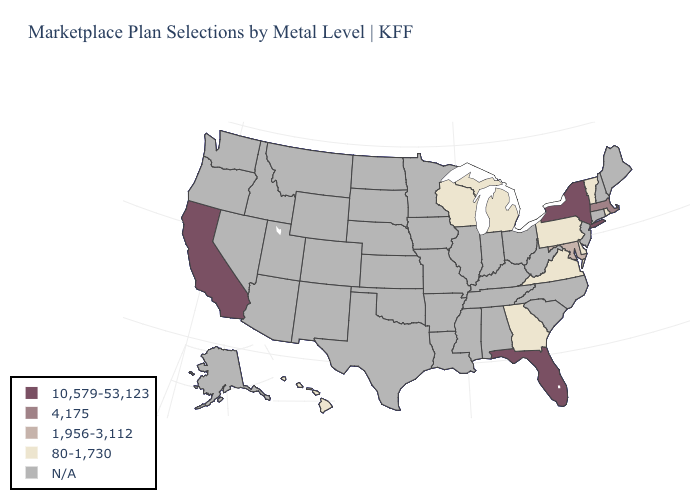What is the value of Vermont?
Give a very brief answer. 80-1,730. Does the map have missing data?
Quick response, please. Yes. Name the states that have a value in the range 10,579-53,123?
Answer briefly. California, Florida, New York. Does the map have missing data?
Be succinct. Yes. What is the lowest value in the USA?
Concise answer only. 80-1,730. Name the states that have a value in the range 4,175?
Write a very short answer. Massachusetts. What is the value of Arizona?
Answer briefly. N/A. Name the states that have a value in the range 10,579-53,123?
Quick response, please. California, Florida, New York. What is the highest value in states that border Kentucky?
Give a very brief answer. 80-1,730. What is the value of New Hampshire?
Be succinct. N/A. Does Florida have the highest value in the South?
Give a very brief answer. Yes. What is the value of Georgia?
Answer briefly. 80-1,730. Does the map have missing data?
Answer briefly. Yes. Which states hav the highest value in the West?
Keep it brief. California. Which states have the lowest value in the USA?
Keep it brief. Delaware, Georgia, Hawaii, Michigan, Pennsylvania, Rhode Island, Vermont, Virginia, Wisconsin. 